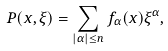<formula> <loc_0><loc_0><loc_500><loc_500>P ( x , \xi ) = \sum _ { | \alpha | \leq n } f _ { \alpha } ( x ) \xi ^ { \alpha } ,</formula> 